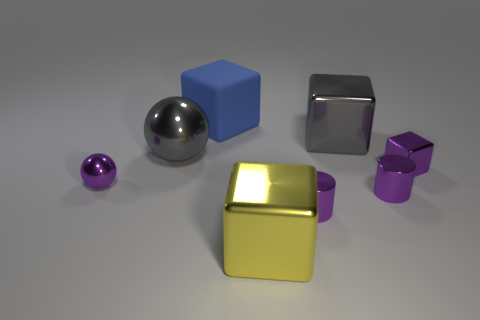Add 2 cylinders. How many objects exist? 10 Subtract all large blue rubber cubes. How many cubes are left? 3 Subtract all gray spheres. How many spheres are left? 1 Subtract 1 balls. How many balls are left? 1 Subtract all shiny cubes. Subtract all big shiny cubes. How many objects are left? 3 Add 2 small purple objects. How many small purple objects are left? 6 Add 5 large yellow shiny balls. How many large yellow shiny balls exist? 5 Subtract 0 cyan cylinders. How many objects are left? 8 Subtract all red cylinders. Subtract all purple spheres. How many cylinders are left? 2 